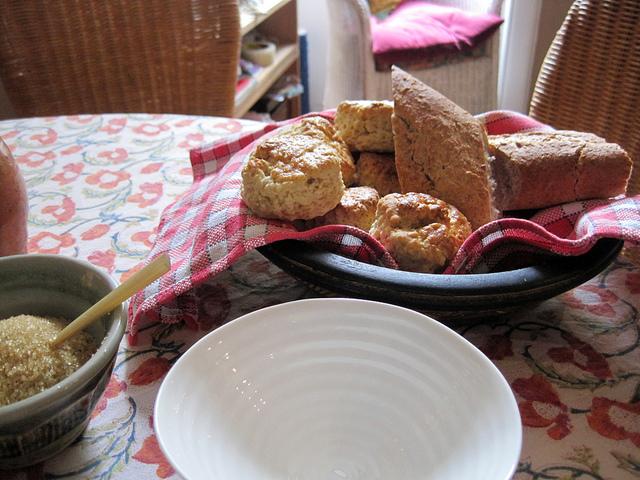What type of bowl's are there?
Keep it brief. Glass. What bread types are shown?
Short answer required. Scones. Is the table cloth patterned?
Write a very short answer. Yes. 